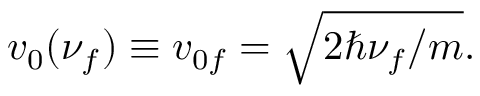<formula> <loc_0><loc_0><loc_500><loc_500>v _ { 0 } ( \nu _ { f } ) \equiv v _ { 0 f } = \sqrt { 2 \hbar { \nu } _ { f } / m } .</formula> 